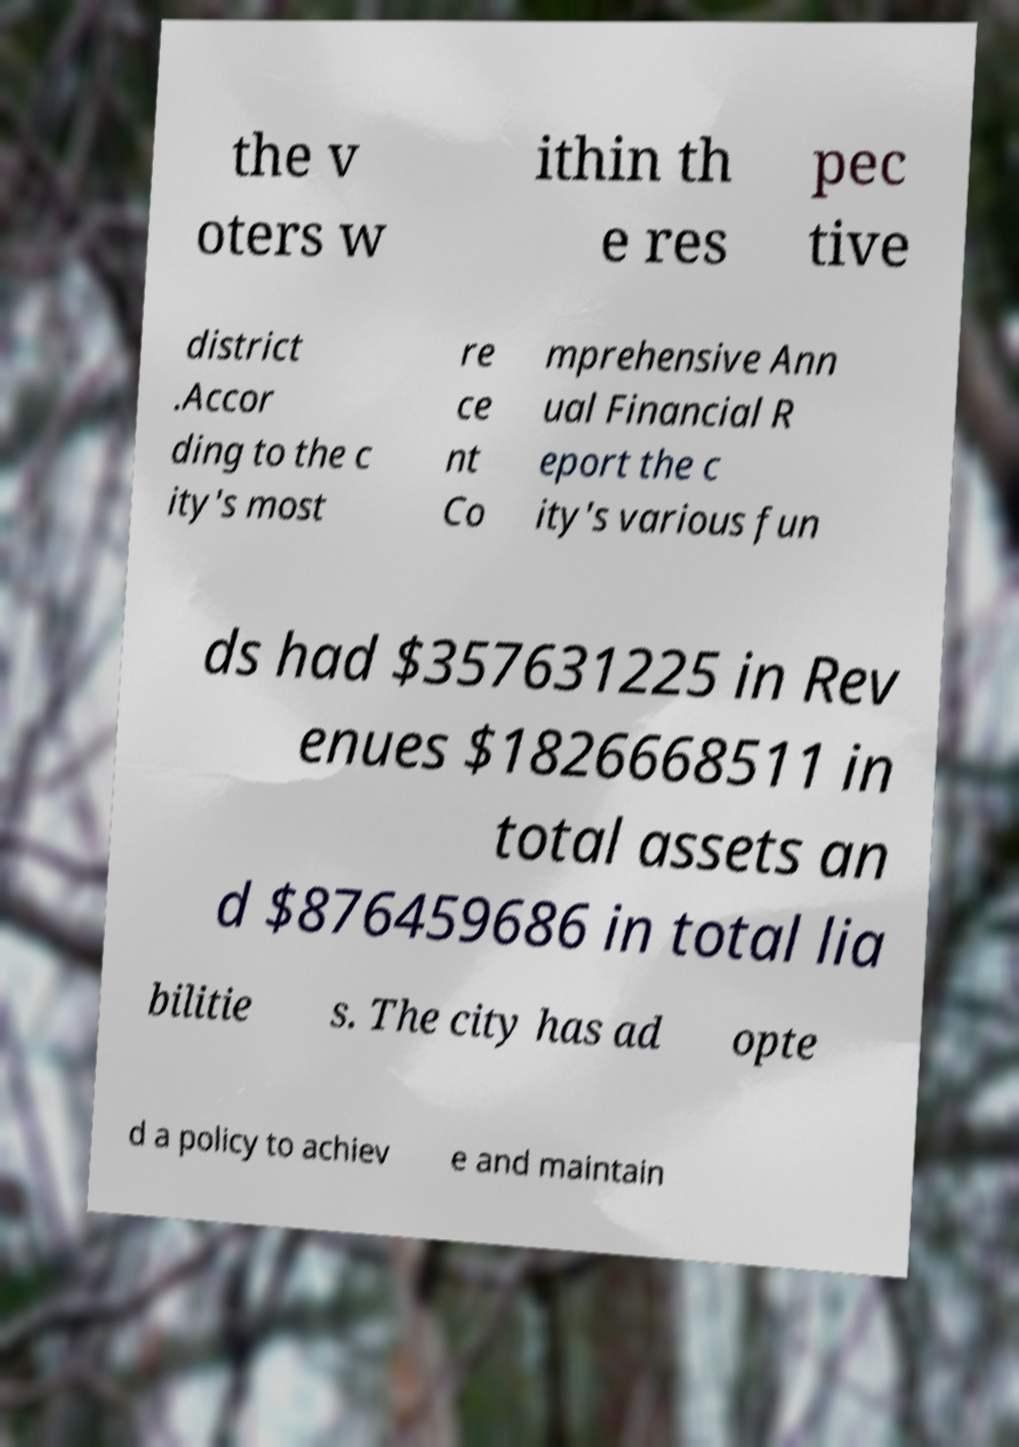Could you extract and type out the text from this image? the v oters w ithin th e res pec tive district .Accor ding to the c ity's most re ce nt Co mprehensive Ann ual Financial R eport the c ity's various fun ds had $357631225 in Rev enues $1826668511 in total assets an d $876459686 in total lia bilitie s. The city has ad opte d a policy to achiev e and maintain 